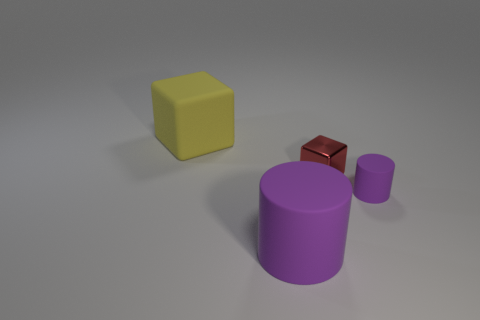What is the shape of the large matte object that is in front of the tiny purple matte cylinder?
Offer a terse response. Cylinder. There is a rubber object that is the same color as the tiny rubber cylinder; what is its shape?
Your answer should be compact. Cylinder. How many purple matte cylinders have the same size as the red block?
Provide a short and direct response. 1. The tiny metal cube has what color?
Your answer should be compact. Red. There is a matte cube; does it have the same color as the cylinder that is to the left of the red object?
Offer a very short reply. No. The yellow block that is the same material as the big purple cylinder is what size?
Make the answer very short. Large. Is there another rubber block that has the same color as the rubber block?
Provide a succinct answer. No. How many things are rubber things in front of the yellow rubber object or red metallic cubes?
Your answer should be very brief. 3. Do the red thing and the purple cylinder right of the tiny red block have the same material?
Make the answer very short. No. What is the size of the other cylinder that is the same color as the tiny cylinder?
Offer a terse response. Large. 